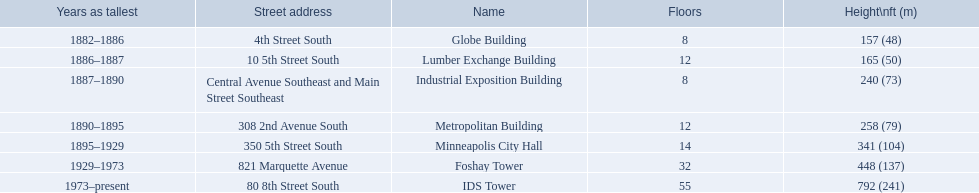What are the tallest buildings in minneapolis? Globe Building, Lumber Exchange Building, Industrial Exposition Building, Metropolitan Building, Minneapolis City Hall, Foshay Tower, IDS Tower. What is the height of the metropolitan building? 258 (79). What is the height of the lumber exchange building? 165 (50). Of those two which is taller? Metropolitan Building. 